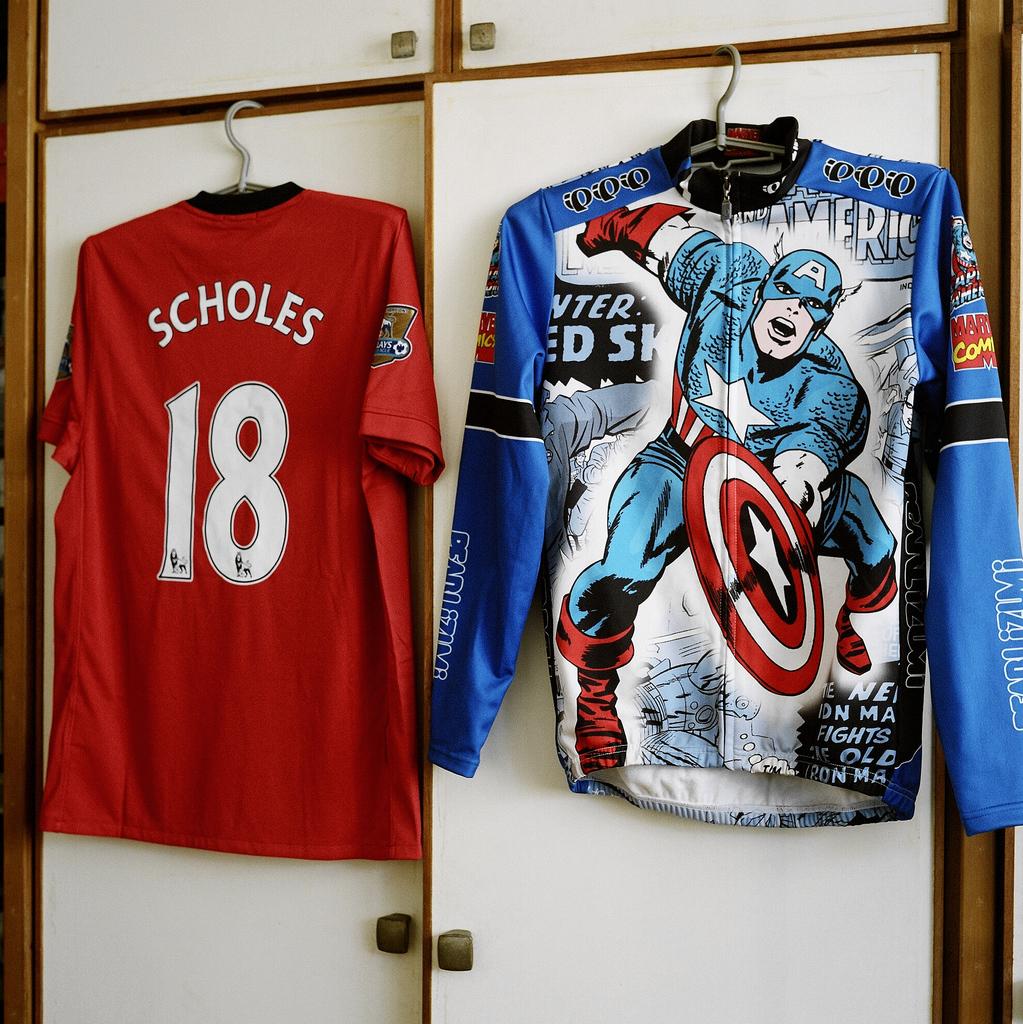What number is the jersey?
Offer a very short reply. 18. 